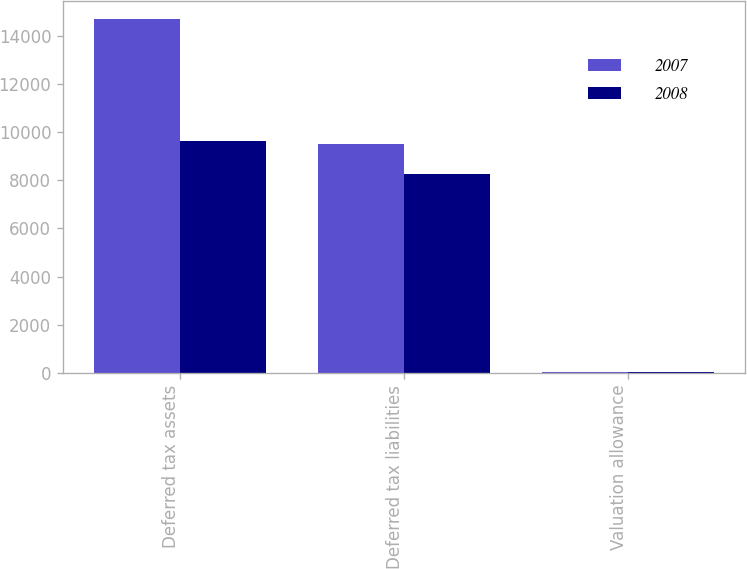Convert chart. <chart><loc_0><loc_0><loc_500><loc_500><stacked_bar_chart><ecel><fcel>Deferred tax assets<fcel>Deferred tax liabilities<fcel>Valuation allowance<nl><fcel>2007<fcel>14700<fcel>9492<fcel>48<nl><fcel>2008<fcel>9640<fcel>8272<fcel>20<nl></chart> 